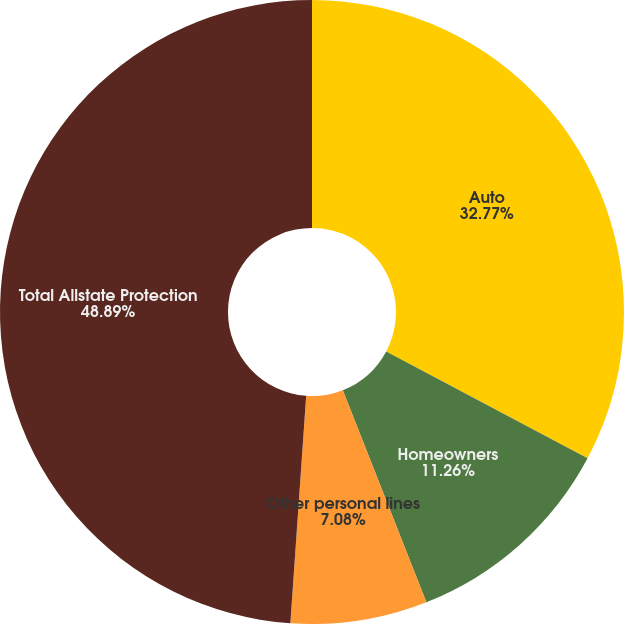<chart> <loc_0><loc_0><loc_500><loc_500><pie_chart><fcel>Auto<fcel>Homeowners<fcel>Other personal lines<fcel>Total Allstate Protection<nl><fcel>32.77%<fcel>11.26%<fcel>7.08%<fcel>48.9%<nl></chart> 